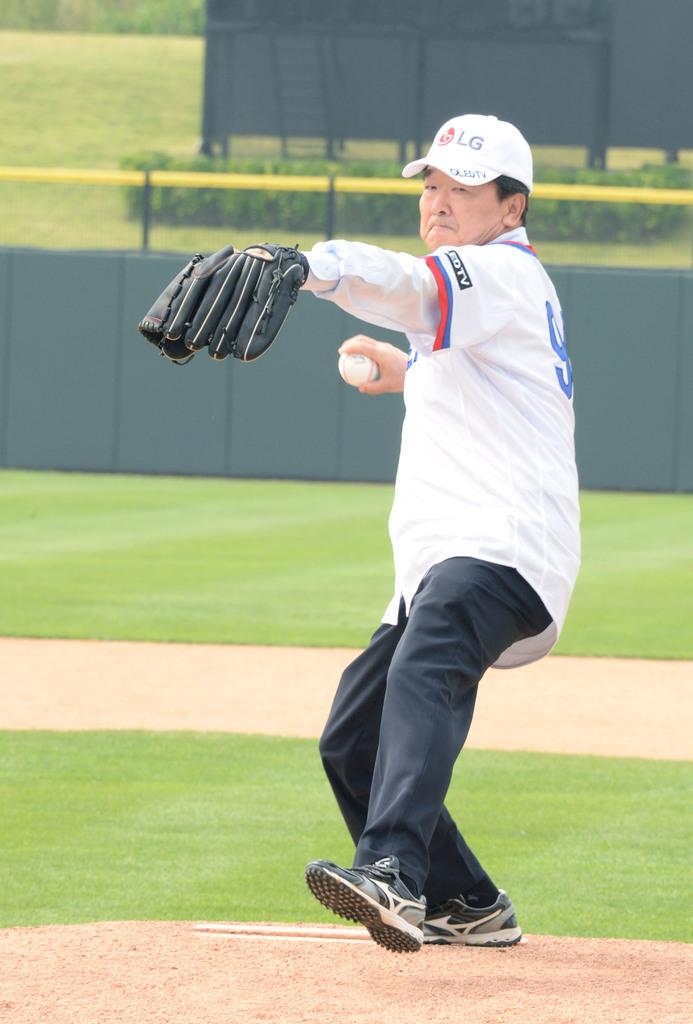What does his hat say?
Ensure brevity in your answer.  Lg. What letters are visible in black on his jersey?
Offer a terse response. Edtv. 